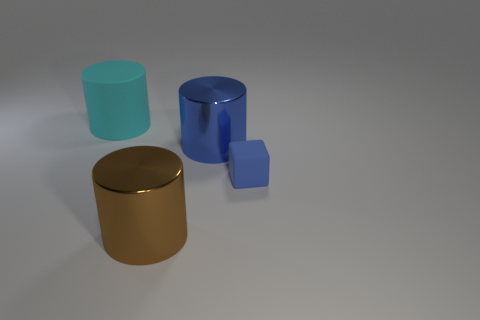Subtract all brown cylinders. How many cylinders are left? 2 Add 2 blue metal cylinders. How many objects exist? 6 Subtract all cyan cylinders. How many cylinders are left? 2 Subtract 1 cylinders. How many cylinders are left? 2 Subtract all cylinders. How many objects are left? 1 Subtract 0 blue balls. How many objects are left? 4 Subtract all yellow cylinders. Subtract all green cubes. How many cylinders are left? 3 Subtract all brown metal cubes. Subtract all cyan matte cylinders. How many objects are left? 3 Add 1 big blue things. How many big blue things are left? 2 Add 3 small rubber cubes. How many small rubber cubes exist? 4 